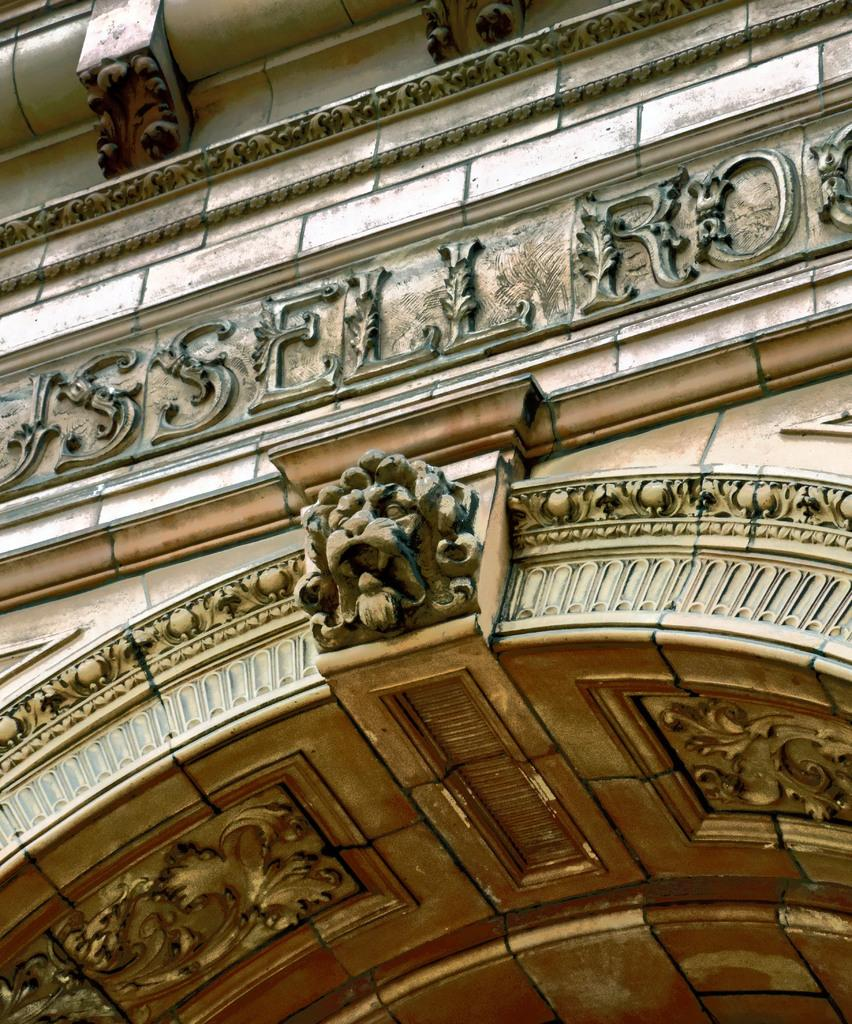What is the main feature of the image? There is a wall in the image. How is the wall depicted? The wall appears to be truncated. What can be seen on the wall? There is text and a sculpture on the wall. Is there any smoke coming from the blade in the image? There is no blade or smoke present in the image. 